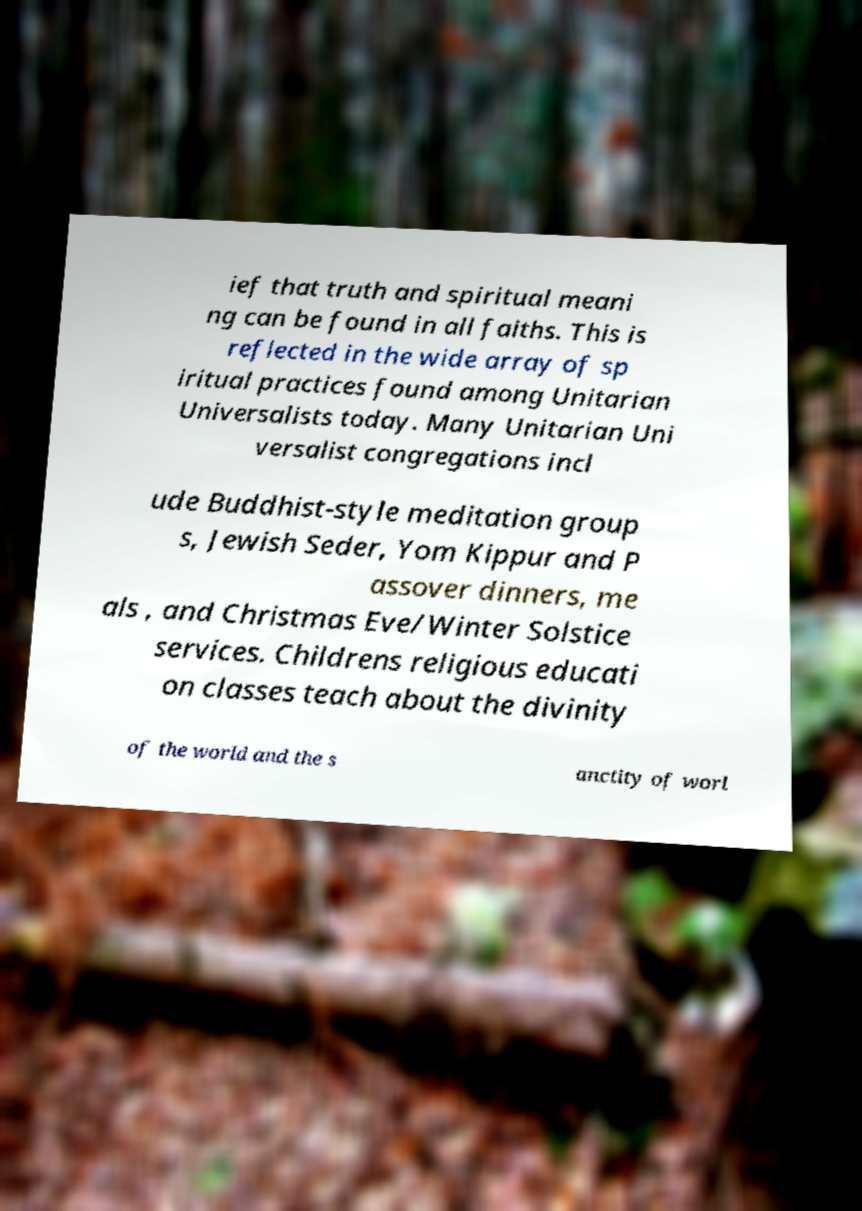Could you assist in decoding the text presented in this image and type it out clearly? ief that truth and spiritual meani ng can be found in all faiths. This is reflected in the wide array of sp iritual practices found among Unitarian Universalists today. Many Unitarian Uni versalist congregations incl ude Buddhist-style meditation group s, Jewish Seder, Yom Kippur and P assover dinners, me als , and Christmas Eve/Winter Solstice services. Childrens religious educati on classes teach about the divinity of the world and the s anctity of worl 